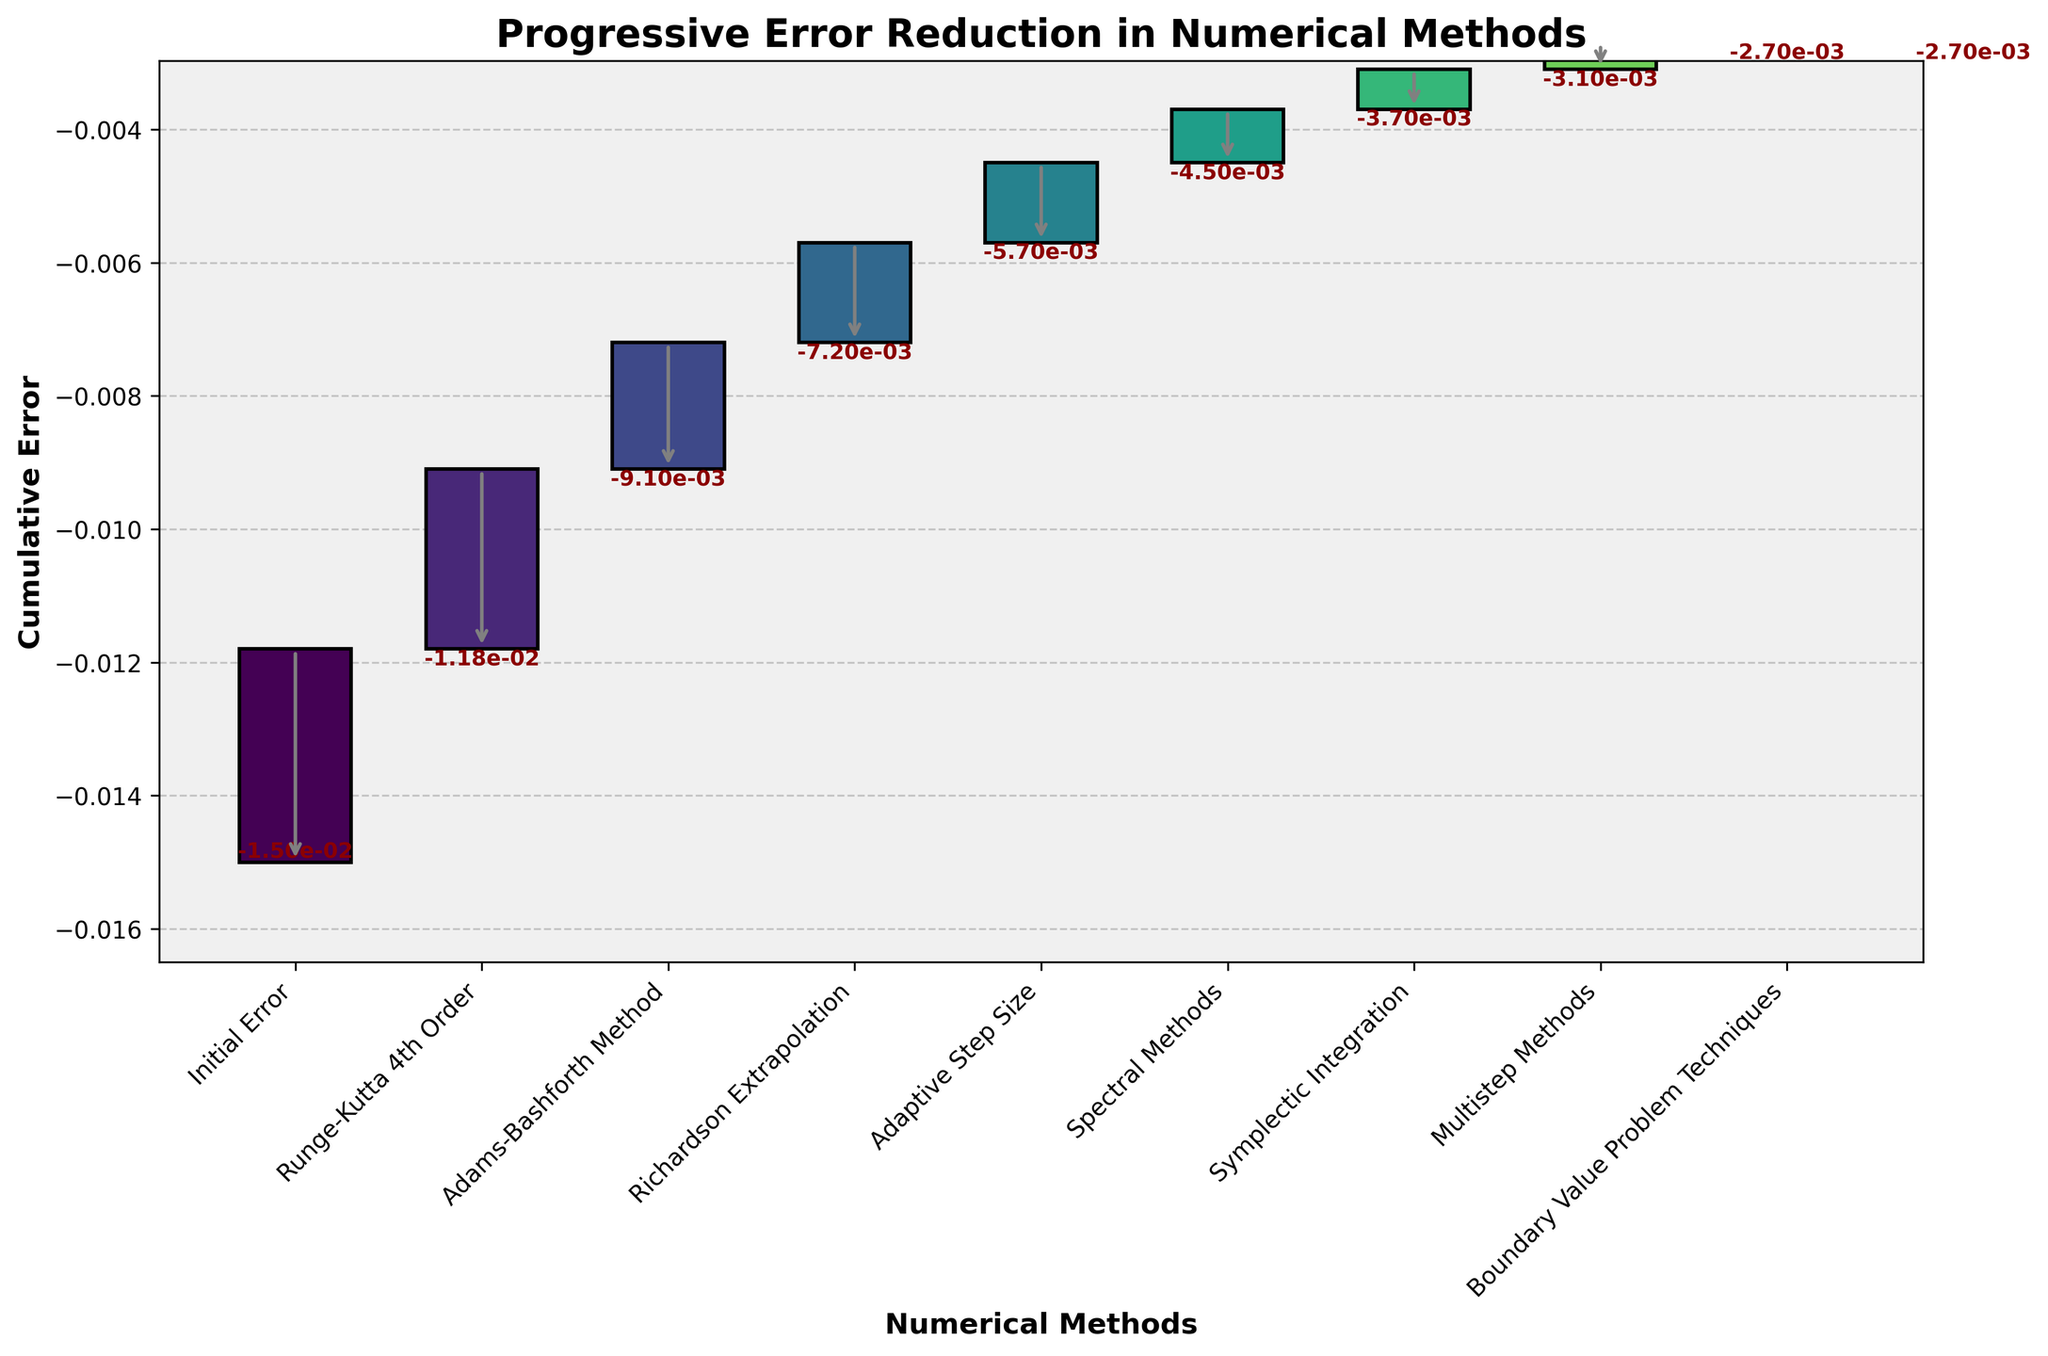What is the initial error? The initial error is located at the first data point on the chart under the label 'Initial Error'. The figure shows this value as -1.5e-2.
Answer: -1.5e-2 What is the cumulative error after applying the Runge-Kutta 4th Order method? The cumulative error after the Runge-Kutta 4th Order method can be found after this step, labeled specifically in the chart. The value is -1.18e-2.
Answer: -1.18e-2 Which numerical method contributes the largest reduction in error? To determine the largest reduction, compare the "Error Reduction" values for each method. The Runge-Kutta 4th Order method reduces the error by -3.2e-3, the largest among the listed methods.
Answer: Runge-Kutta 4th Order How much does the error reduce by when using Adaptive Step Size compared to the previous method? The previous method is Richardson Extrapolation with a cumulative error of -7.2e-3, and Adaptive Step Size reduces it further to -5.7e-3. The error reduction difference is -7.2e-3 - (-5.7e-3) = -1.5e-3.
Answer: -1.5e-3 What is the cumulative error after applying Symplectic Integration? Locate the value corresponding to Symplectic Integration on the chart. The cumulative error is -3.7e-3.
Answer: -3.7e-3 How many numerical methods are used in total excluding the Initial and Final Error? Counting the list of steps excluding 'Initial Error' and 'Final Error' gives us 8 methods.
Answer: 8 Which numerical method shows the least reduction in error? By comparing all error reduction values, the Multistep Methods show the smallest reduction at -6.0e-4.
Answer: Multistep Methods What is the total error reduction achieved from the initial to final error? The initial error is -1.5e-2, and the final error is -2.7e-3. So, the total reduction is -1.5e-2 - (-2.7e-3) = -1.23e-2.
Answer: -1.23e-2 Between Spectral Methods and Multistep Methods, which has a larger cumulative error and by how much? Spectral Methods have a cumulative error of -4.5e-3, and Multistep Methods have -3.1e-3. The difference is -3.1e-3 - (-4.5e-3) = 1.4e-3.
Answer: Spectral Methods, 1.4e-3 